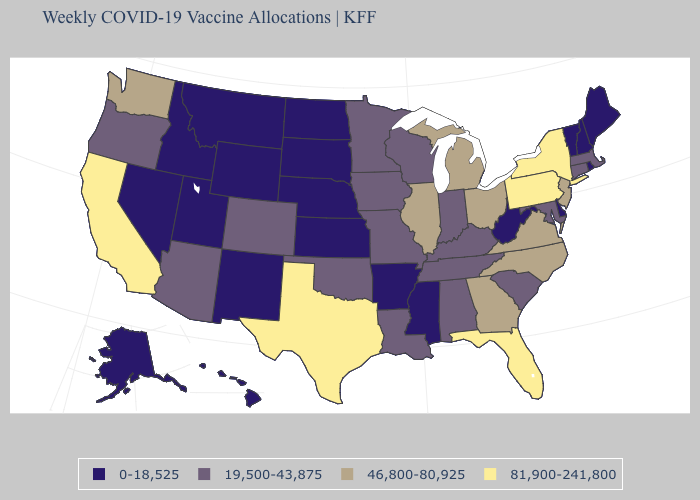Name the states that have a value in the range 19,500-43,875?
Short answer required. Alabama, Arizona, Colorado, Connecticut, Indiana, Iowa, Kentucky, Louisiana, Maryland, Massachusetts, Minnesota, Missouri, Oklahoma, Oregon, South Carolina, Tennessee, Wisconsin. Among the states that border Virginia , which have the highest value?
Give a very brief answer. North Carolina. Among the states that border Virginia , does West Virginia have the lowest value?
Answer briefly. Yes. Name the states that have a value in the range 19,500-43,875?
Concise answer only. Alabama, Arizona, Colorado, Connecticut, Indiana, Iowa, Kentucky, Louisiana, Maryland, Massachusetts, Minnesota, Missouri, Oklahoma, Oregon, South Carolina, Tennessee, Wisconsin. Among the states that border Nevada , which have the lowest value?
Give a very brief answer. Idaho, Utah. What is the highest value in the USA?
Quick response, please. 81,900-241,800. Name the states that have a value in the range 46,800-80,925?
Keep it brief. Georgia, Illinois, Michigan, New Jersey, North Carolina, Ohio, Virginia, Washington. What is the highest value in the USA?
Answer briefly. 81,900-241,800. Does West Virginia have the lowest value in the South?
Concise answer only. Yes. What is the value of South Carolina?
Concise answer only. 19,500-43,875. What is the value of Alabama?
Answer briefly. 19,500-43,875. Does Wisconsin have a higher value than Arkansas?
Be succinct. Yes. Does Alabama have a lower value than Florida?
Be succinct. Yes. What is the highest value in the MidWest ?
Keep it brief. 46,800-80,925. 